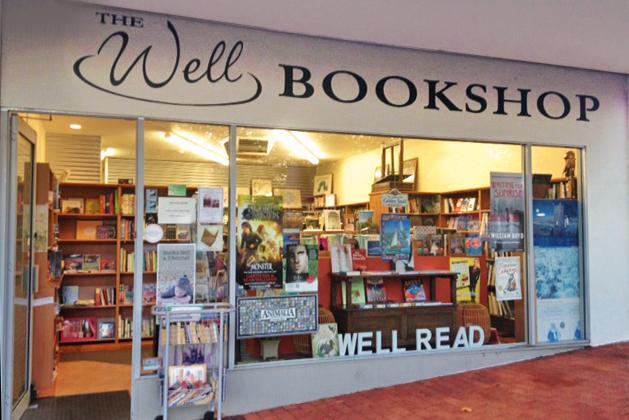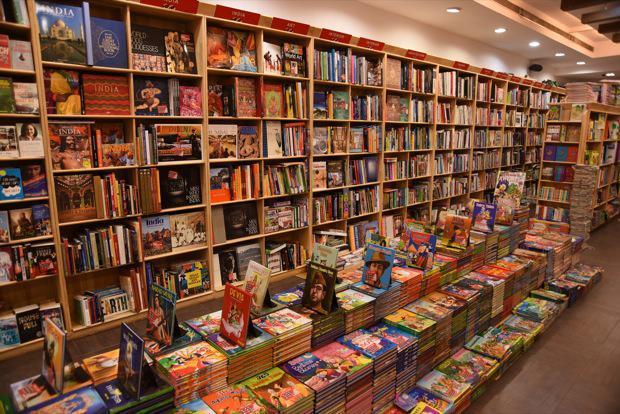The first image is the image on the left, the second image is the image on the right. Considering the images on both sides, is "A container of flowers sits on a table in one of the bookstore images." valid? Answer yes or no. No. The first image is the image on the left, the second image is the image on the right. Examine the images to the left and right. Is the description "No customers can be seen in either bookshop image." accurate? Answer yes or no. Yes. 